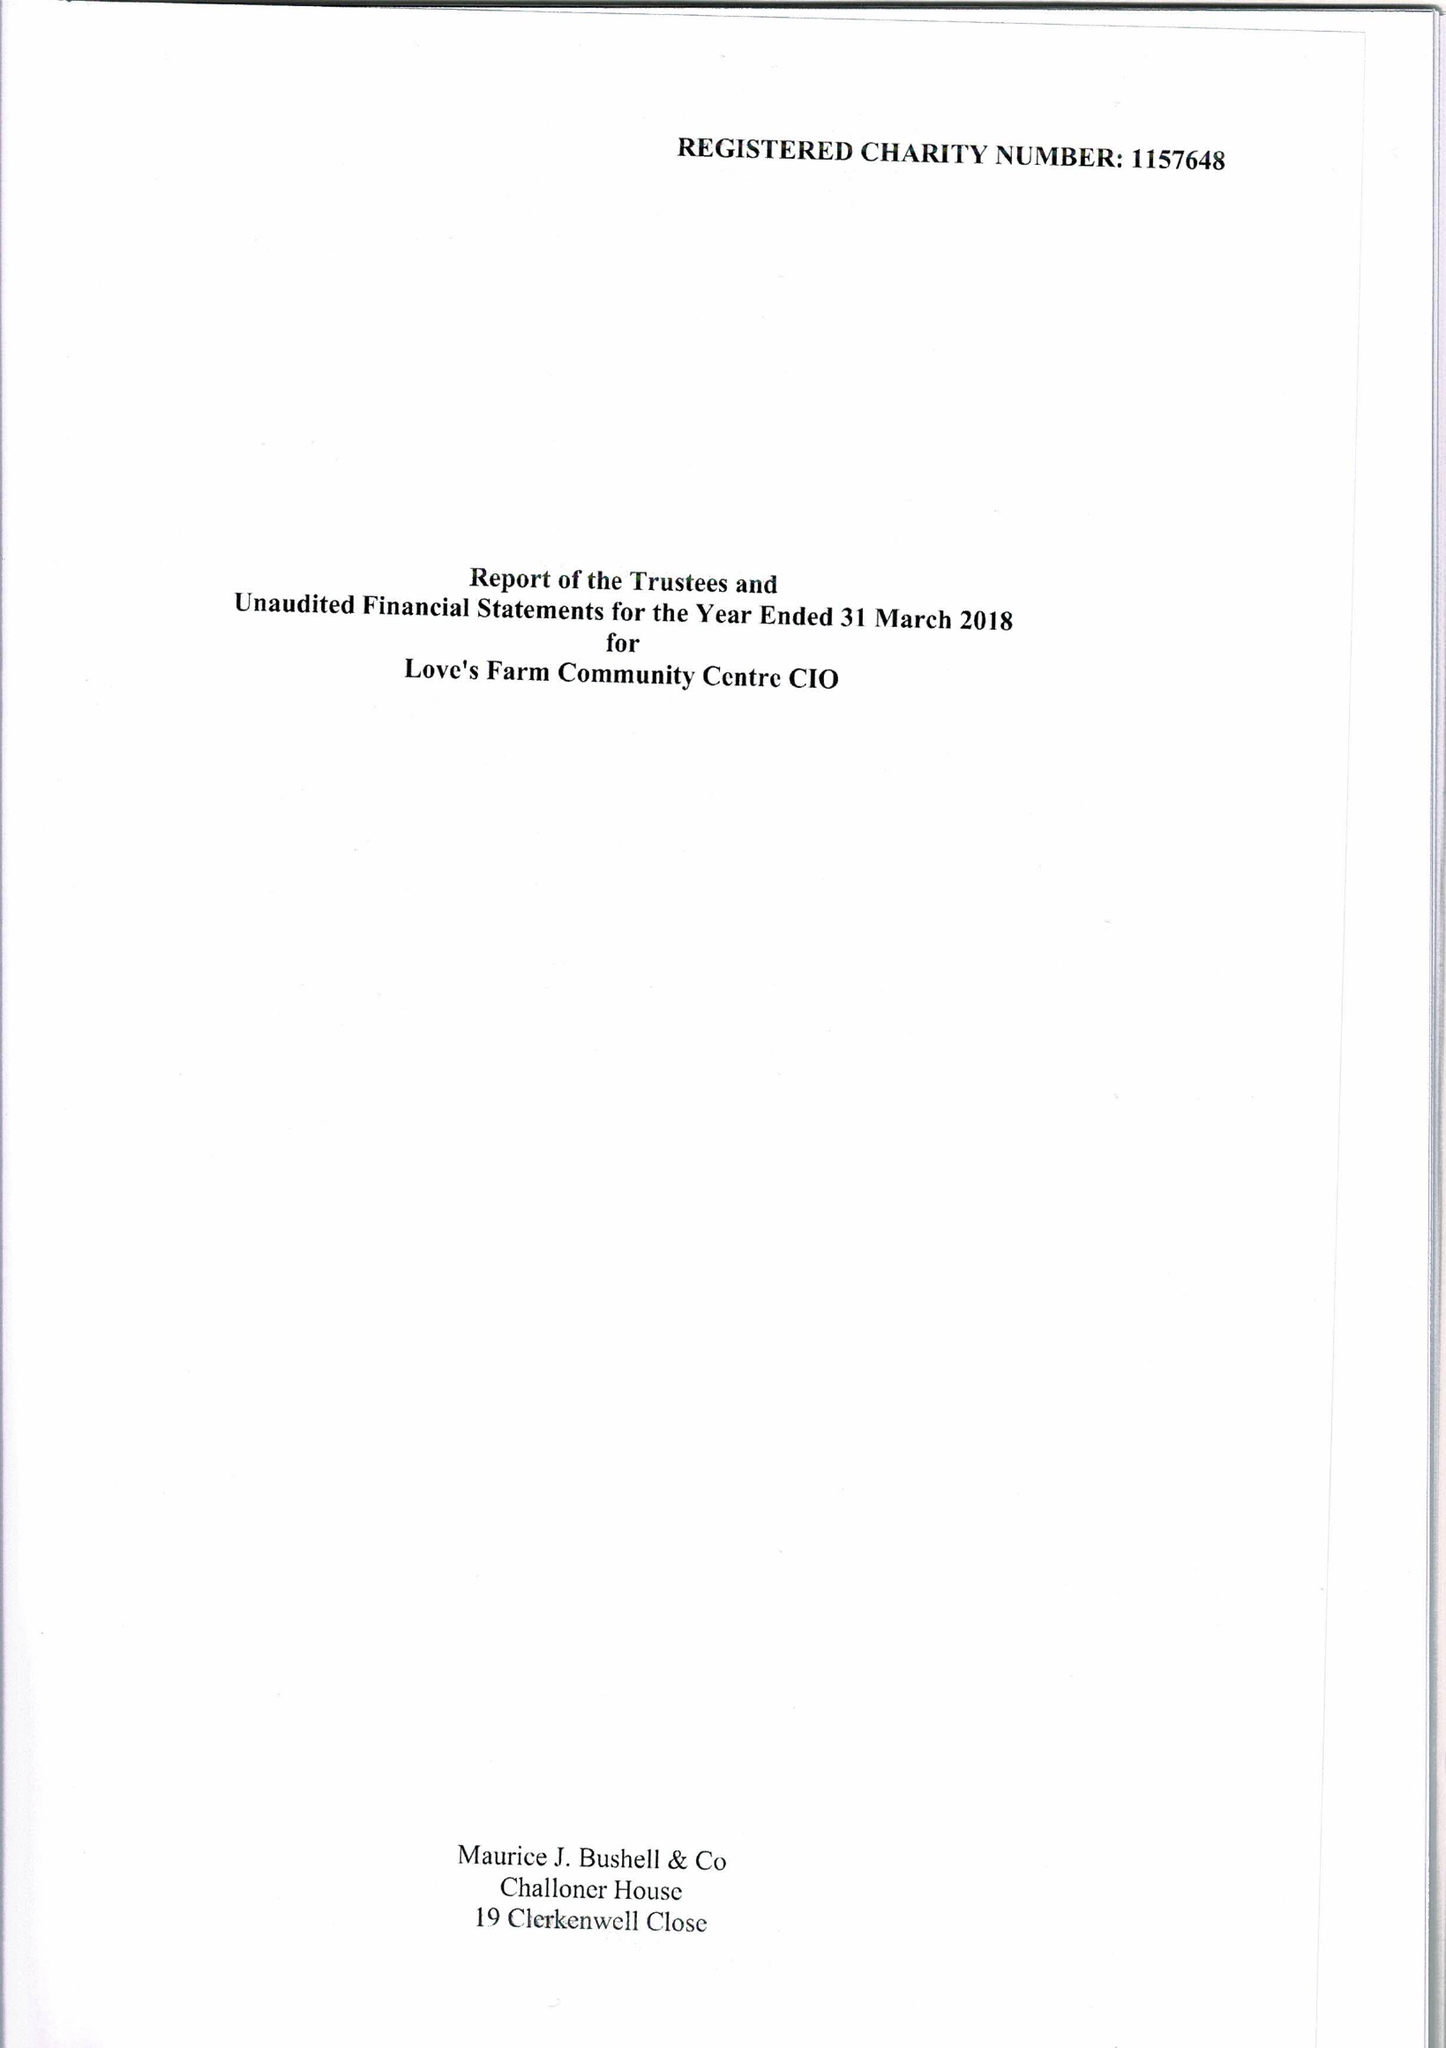What is the value for the report_date?
Answer the question using a single word or phrase. 2018-03-31 